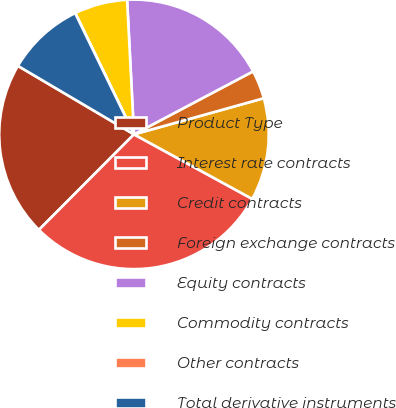Convert chart to OTSL. <chart><loc_0><loc_0><loc_500><loc_500><pie_chart><fcel>Product Type<fcel>Interest rate contracts<fcel>Credit contracts<fcel>Foreign exchange contracts<fcel>Equity contracts<fcel>Commodity contracts<fcel>Other contracts<fcel>Total derivative instruments<nl><fcel>21.02%<fcel>29.51%<fcel>12.27%<fcel>3.42%<fcel>18.07%<fcel>6.37%<fcel>0.01%<fcel>9.32%<nl></chart> 